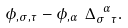Convert formula to latex. <formula><loc_0><loc_0><loc_500><loc_500>\phi _ { , \sigma , \tau } - \phi _ { , \alpha } \ \Delta _ { \sigma \ \tau } ^ { \ \alpha } .</formula> 